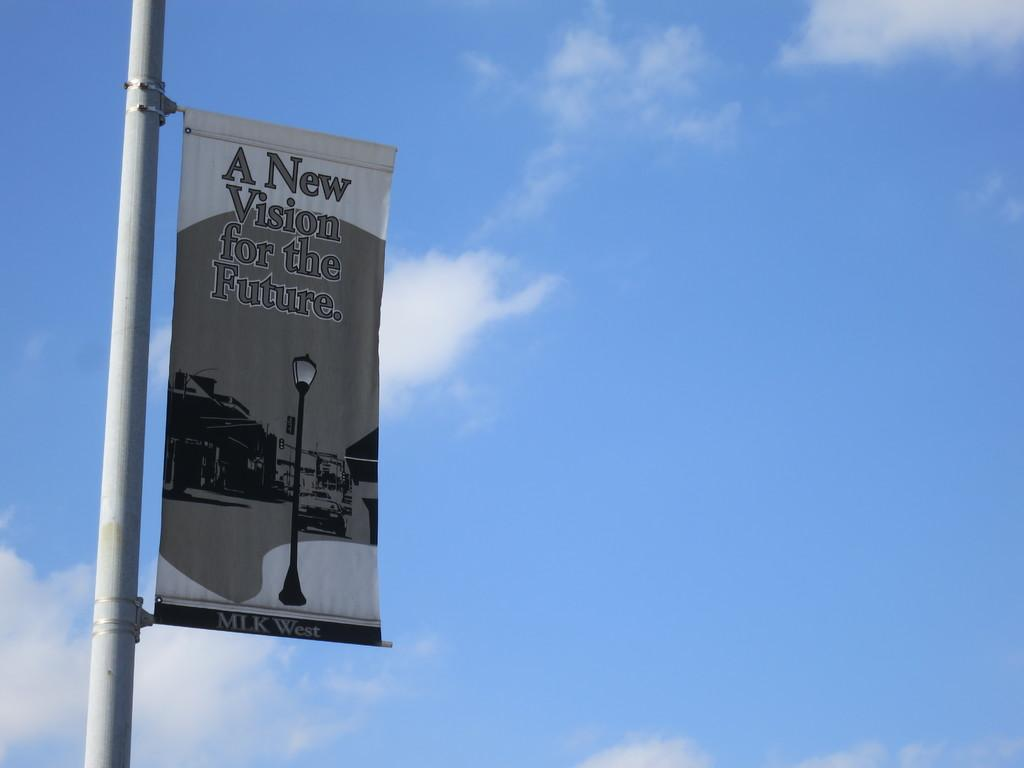<image>
Provide a brief description of the given image. Sign on a pole that reads "A New Vision for the Future". 